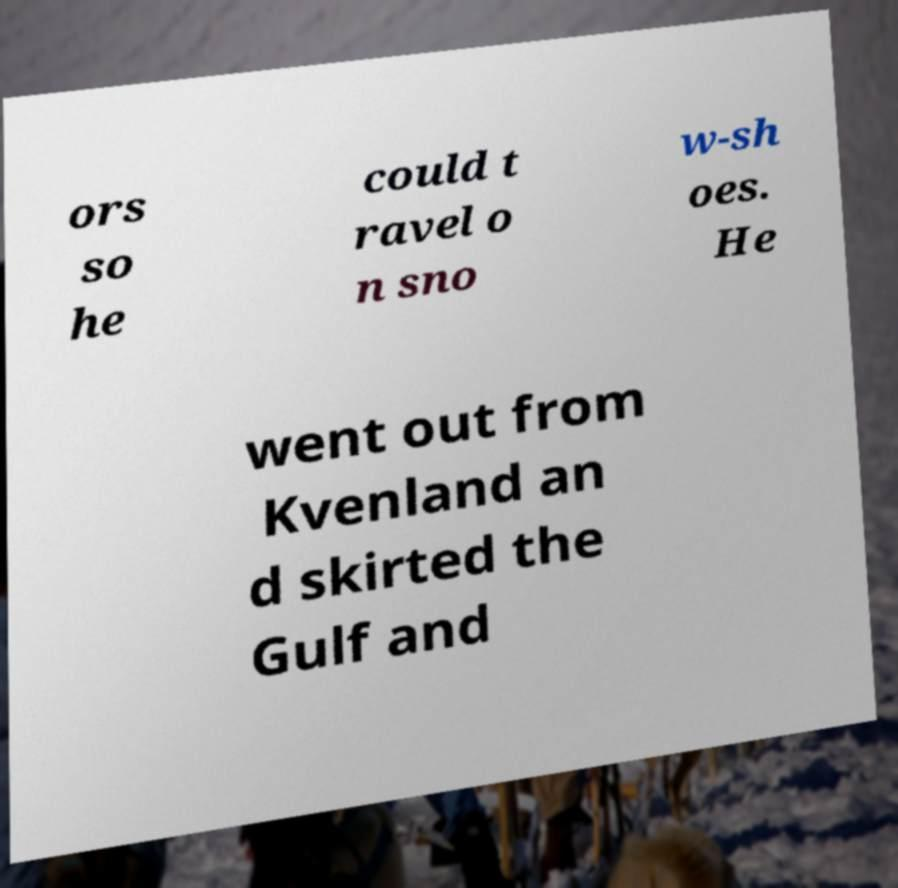Please read and relay the text visible in this image. What does it say? ors so he could t ravel o n sno w-sh oes. He went out from Kvenland an d skirted the Gulf and 